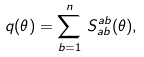<formula> <loc_0><loc_0><loc_500><loc_500>q ( \theta ) = \sum _ { b = 1 } ^ { n } \, S ^ { a b } _ { a b } ( \theta ) ,</formula> 